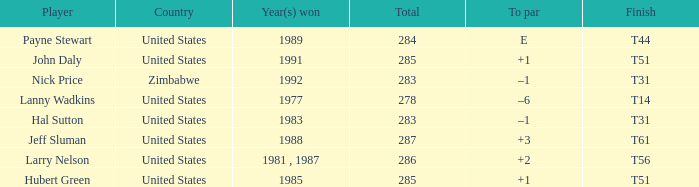Could you parse the entire table as a dict? {'header': ['Player', 'Country', 'Year(s) won', 'Total', 'To par', 'Finish'], 'rows': [['Payne Stewart', 'United States', '1989', '284', 'E', 'T44'], ['John Daly', 'United States', '1991', '285', '+1', 'T51'], ['Nick Price', 'Zimbabwe', '1992', '283', '–1', 'T31'], ['Lanny Wadkins', 'United States', '1977', '278', '–6', 'T14'], ['Hal Sutton', 'United States', '1983', '283', '–1', 'T31'], ['Jeff Sluman', 'United States', '1988', '287', '+3', 'T61'], ['Larry Nelson', 'United States', '1981 , 1987', '286', '+2', 'T56'], ['Hubert Green', 'United States', '1985', '285', '+1', 'T51']]} What is Finish, when Year(s) Won is "1991"? T51. 